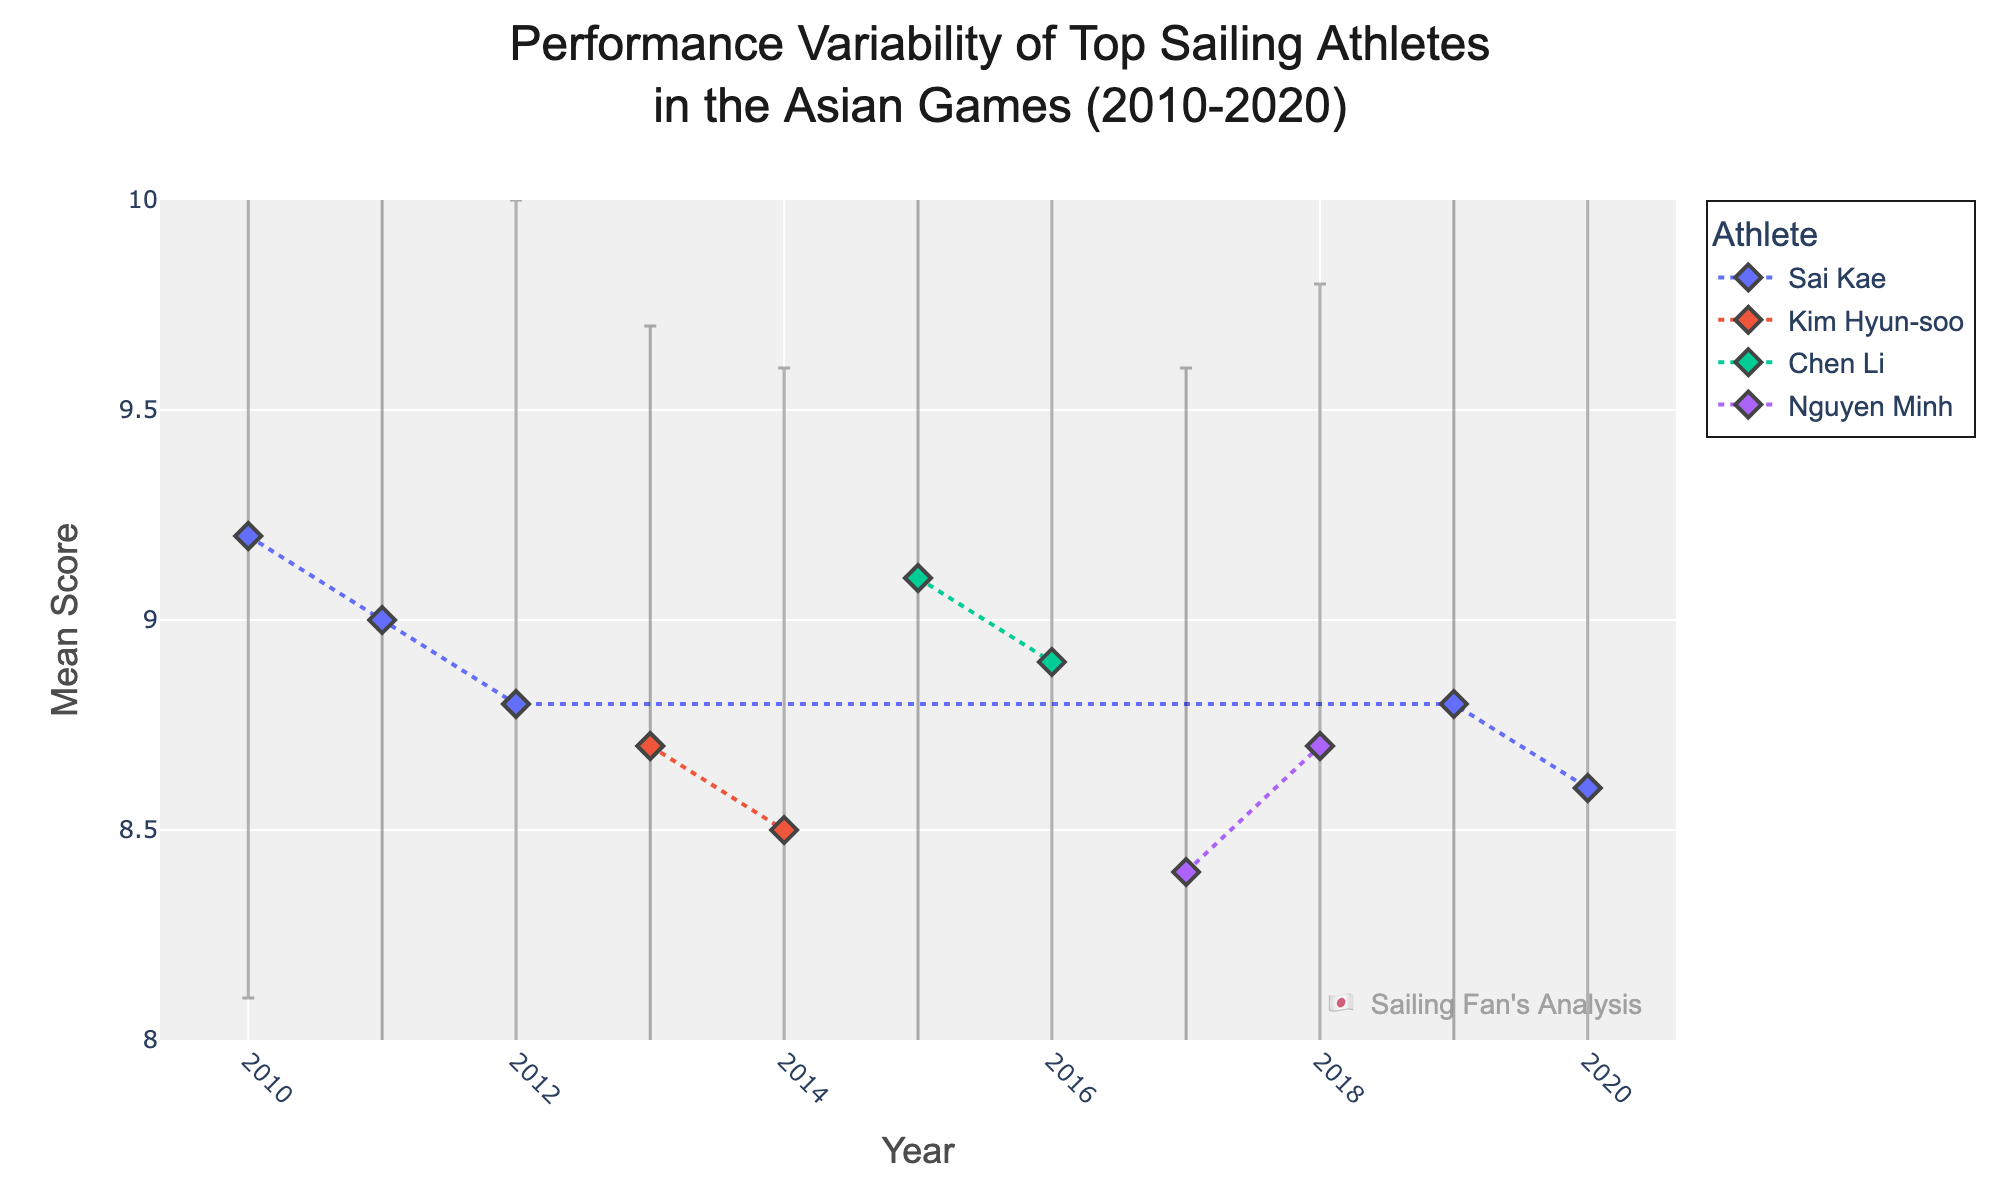What is the title of the figure? The title can be found at the top of the figure. It reads, "Performance Variability of Top Sailing Athletes in the Asian Games (2010-2020)."
Answer: Performance Variability of Top Sailing Athletes in the Asian Games (2010-2020) Which country is represented by the athlete Kim Hyun-soo? By looking at the legend and the label, Kim Hyun-soo is an athlete from South Korea.
Answer: South Korea What is the mean score of Sai Kae in 2010? Locate the year 2010 on the x-axis and observe the corresponding data point for Sai Kae. The mean score is provided near the data point.
Answer: 9.2 In which year did Nguyen Minh have the highest mean score? Find Nguyen Minh's data points and compare the mean scores. The highest mean score for Nguyen Minh is in 2018.
Answer: 2018 How does the performance variability of Chen Li in 2016 compare to 2015? Observe the error bars for Chen Li in 2015 and 2016. The error bars represent the standard deviation, which indicates performance variability. Chen Li's standard deviation in 2016 (1.3) is lower than in 2015 (1.4).
Answer: Lower in 2016 What is the average mean score of Sai Kae across all the years she competed? Calculate the mean scores of Sai Kae in 2010, 2011, 2012, 2019, and 2020. Sum these scores (9.2 + 9.0 + 8.8 + 8.8 + 8.6) and divide by the number of years (5).
Answer: 8.88 Which athlete has the highest peak mean score over any year, and what is that score? Find the highest data point in the figure across all athletes. Chen Li in 2015 has the highest mean score of 9.1.
Answer: Chen Li with 9.1 Was Kim Hyun-soo's performance more stable in 2013 or 2014? Compare the lengths of the error bars for Kim Hyun-soo in 2013 and 2014. The shorter the error bar, the more stable the performance. The error bar in 2013 (1.0) is shorter than in 2014 (1.1).
Answer: 2013 What is the range of mean scores for Nguyen Minh? Determine the minimum and maximum mean scores for Nguyen Minh. The scores are 8.4 (2017) and 8.7 (2018). The range is 8.7 - 8.4.
Answer: 0.3 Compare the general trend in mean scores for Sai Kae from 2010 to 2020. Observe the trend of data points for Sai Kae from 2010 to 2020. The scores show a slight declining trend over the years.
Answer: Slightly declining 